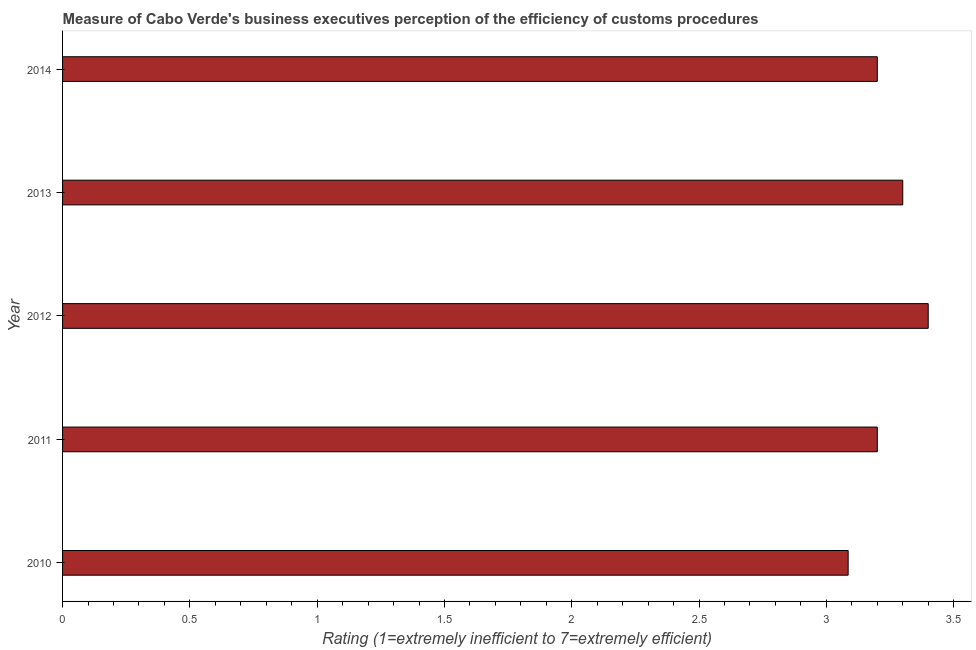Does the graph contain any zero values?
Offer a very short reply. No. What is the title of the graph?
Offer a very short reply. Measure of Cabo Verde's business executives perception of the efficiency of customs procedures. What is the label or title of the X-axis?
Provide a short and direct response. Rating (1=extremely inefficient to 7=extremely efficient). What is the label or title of the Y-axis?
Provide a succinct answer. Year. What is the rating measuring burden of customs procedure in 2014?
Keep it short and to the point. 3.2. Across all years, what is the minimum rating measuring burden of customs procedure?
Your answer should be very brief. 3.09. In which year was the rating measuring burden of customs procedure maximum?
Your answer should be very brief. 2012. What is the sum of the rating measuring burden of customs procedure?
Provide a succinct answer. 16.19. What is the difference between the rating measuring burden of customs procedure in 2012 and 2014?
Give a very brief answer. 0.2. What is the average rating measuring burden of customs procedure per year?
Offer a very short reply. 3.24. Do a majority of the years between 2010 and 2013 (inclusive) have rating measuring burden of customs procedure greater than 0.6 ?
Give a very brief answer. Yes. What is the ratio of the rating measuring burden of customs procedure in 2011 to that in 2013?
Offer a terse response. 0.97. What is the difference between the highest and the second highest rating measuring burden of customs procedure?
Make the answer very short. 0.1. What is the difference between the highest and the lowest rating measuring burden of customs procedure?
Keep it short and to the point. 0.31. How many years are there in the graph?
Keep it short and to the point. 5. What is the Rating (1=extremely inefficient to 7=extremely efficient) in 2010?
Offer a very short reply. 3.09. What is the Rating (1=extremely inefficient to 7=extremely efficient) of 2011?
Offer a terse response. 3.2. What is the Rating (1=extremely inefficient to 7=extremely efficient) of 2012?
Your answer should be very brief. 3.4. What is the Rating (1=extremely inefficient to 7=extremely efficient) in 2013?
Give a very brief answer. 3.3. What is the Rating (1=extremely inefficient to 7=extremely efficient) in 2014?
Give a very brief answer. 3.2. What is the difference between the Rating (1=extremely inefficient to 7=extremely efficient) in 2010 and 2011?
Keep it short and to the point. -0.11. What is the difference between the Rating (1=extremely inefficient to 7=extremely efficient) in 2010 and 2012?
Your answer should be very brief. -0.31. What is the difference between the Rating (1=extremely inefficient to 7=extremely efficient) in 2010 and 2013?
Give a very brief answer. -0.21. What is the difference between the Rating (1=extremely inefficient to 7=extremely efficient) in 2010 and 2014?
Your answer should be compact. -0.11. What is the difference between the Rating (1=extremely inefficient to 7=extremely efficient) in 2011 and 2013?
Provide a short and direct response. -0.1. What is the difference between the Rating (1=extremely inefficient to 7=extremely efficient) in 2012 and 2013?
Your answer should be compact. 0.1. What is the ratio of the Rating (1=extremely inefficient to 7=extremely efficient) in 2010 to that in 2011?
Give a very brief answer. 0.96. What is the ratio of the Rating (1=extremely inefficient to 7=extremely efficient) in 2010 to that in 2012?
Your answer should be very brief. 0.91. What is the ratio of the Rating (1=extremely inefficient to 7=extremely efficient) in 2010 to that in 2013?
Give a very brief answer. 0.94. What is the ratio of the Rating (1=extremely inefficient to 7=extremely efficient) in 2010 to that in 2014?
Make the answer very short. 0.96. What is the ratio of the Rating (1=extremely inefficient to 7=extremely efficient) in 2011 to that in 2012?
Offer a very short reply. 0.94. What is the ratio of the Rating (1=extremely inefficient to 7=extremely efficient) in 2011 to that in 2013?
Your answer should be compact. 0.97. What is the ratio of the Rating (1=extremely inefficient to 7=extremely efficient) in 2011 to that in 2014?
Your response must be concise. 1. What is the ratio of the Rating (1=extremely inefficient to 7=extremely efficient) in 2012 to that in 2014?
Your answer should be compact. 1.06. What is the ratio of the Rating (1=extremely inefficient to 7=extremely efficient) in 2013 to that in 2014?
Offer a terse response. 1.03. 